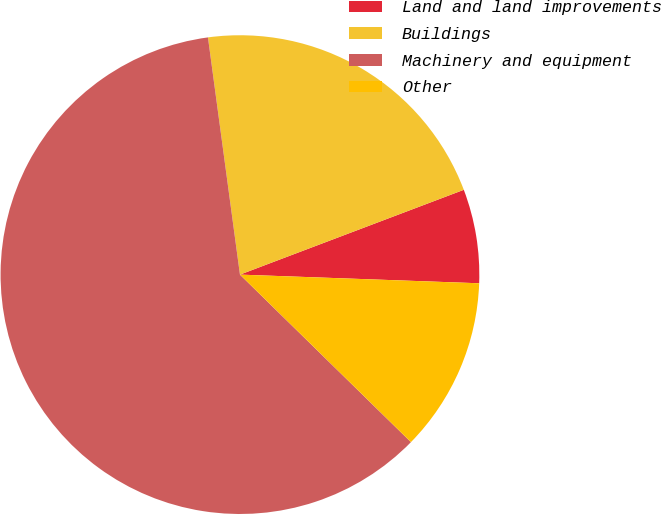Convert chart to OTSL. <chart><loc_0><loc_0><loc_500><loc_500><pie_chart><fcel>Land and land improvements<fcel>Buildings<fcel>Machinery and equipment<fcel>Other<nl><fcel>6.34%<fcel>21.37%<fcel>60.53%<fcel>11.76%<nl></chart> 